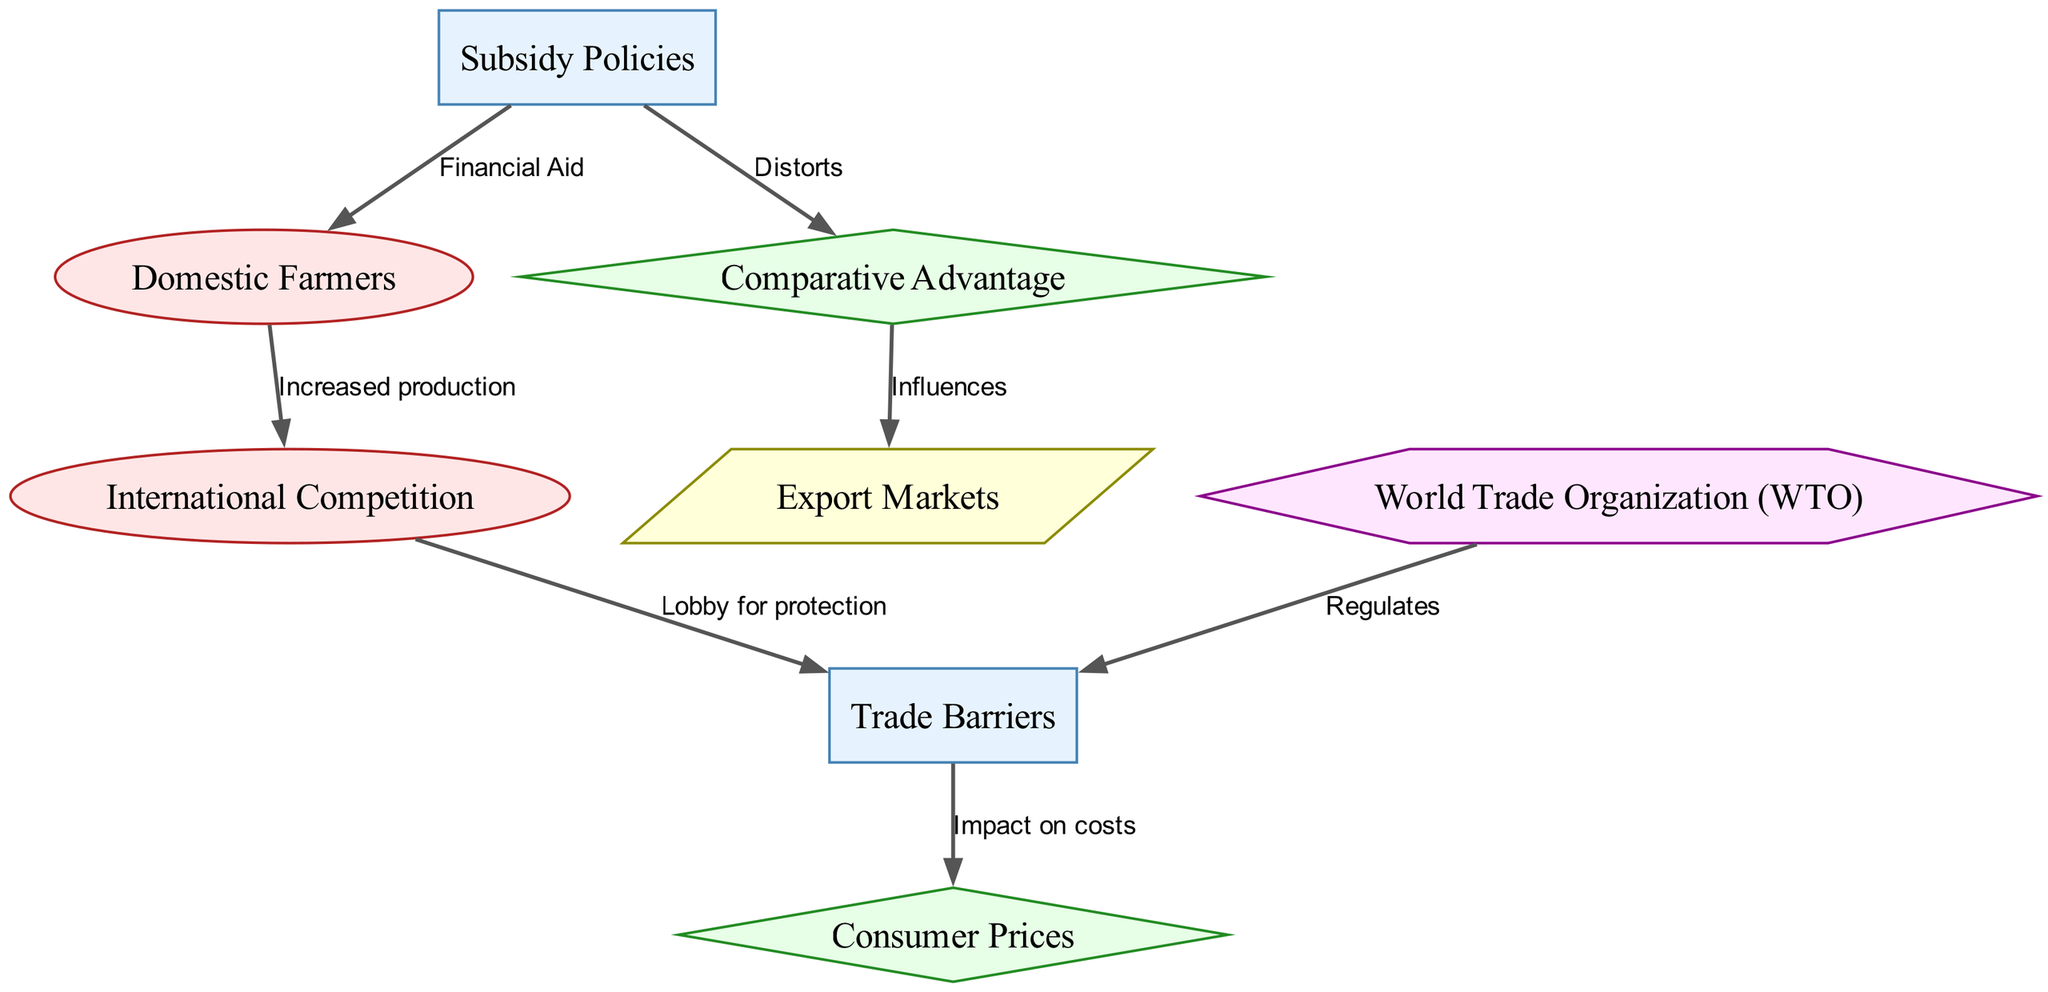What is the label of the node that involves financial aid? The node labeled "Subsidy Policies" is the one associated with financial aid to local agriculture. This can be seen directly from the label of the node.
Answer: Subsidy Policies How many nodes are present in the diagram? By counting the individual entries in the nodes list provided, we see there are 8 nodes. Each node has a distinct identity and label, contributing to the overall diagram.
Answer: 8 What type of entity is "international competition"? The type is indicated in the data structure for that node. "International Competition" is classified under "entity". This classification can be quickly verified by looking at the type associated with this node.
Answer: entity What is the relationship between "trade barriers" and "consumer prices"? The relationship is defined through the edge labeled "Impact on costs" that connects "trade barriers" to "consumer prices". This indicates how trade barriers affect the prices consumers pay for agricultural products.
Answer: Impact on costs What does "subsidy policies" do to "comparative advantage"? "Subsidy policies" distort comparative advantage as expressed in the edge labeled "Distorts" between these two nodes. It shows how government financial support alters the natural comparative advantages that countries might possess.
Answer: Distorts How does "international competition" influence "trade barriers"? The influence is shown through the edge labeled "Lobby for protection," indicating that international competition advocates for trade barriers to protect domestic industries. This shows a flow of influence from competition to policy.
Answer: Lobby for protection Which organization regulates trade barriers? The "World Trade Organization (WTO)" regulates trade barriers, as explicitly connected in the edge labeled "Regulates." This indicates the role of the WTO in overseeing global trade rules impacting agricultural trade.
Answer: World Trade Organization (WTO) What is impacted by trade barriers according to the diagram? The diagram indicates that trade barriers impact consumer prices, as shown in the edge labeled "Impact on costs." This makes it clear that consumer prices are affected by the imposition of trade barriers.
Answer: Consumer Prices 